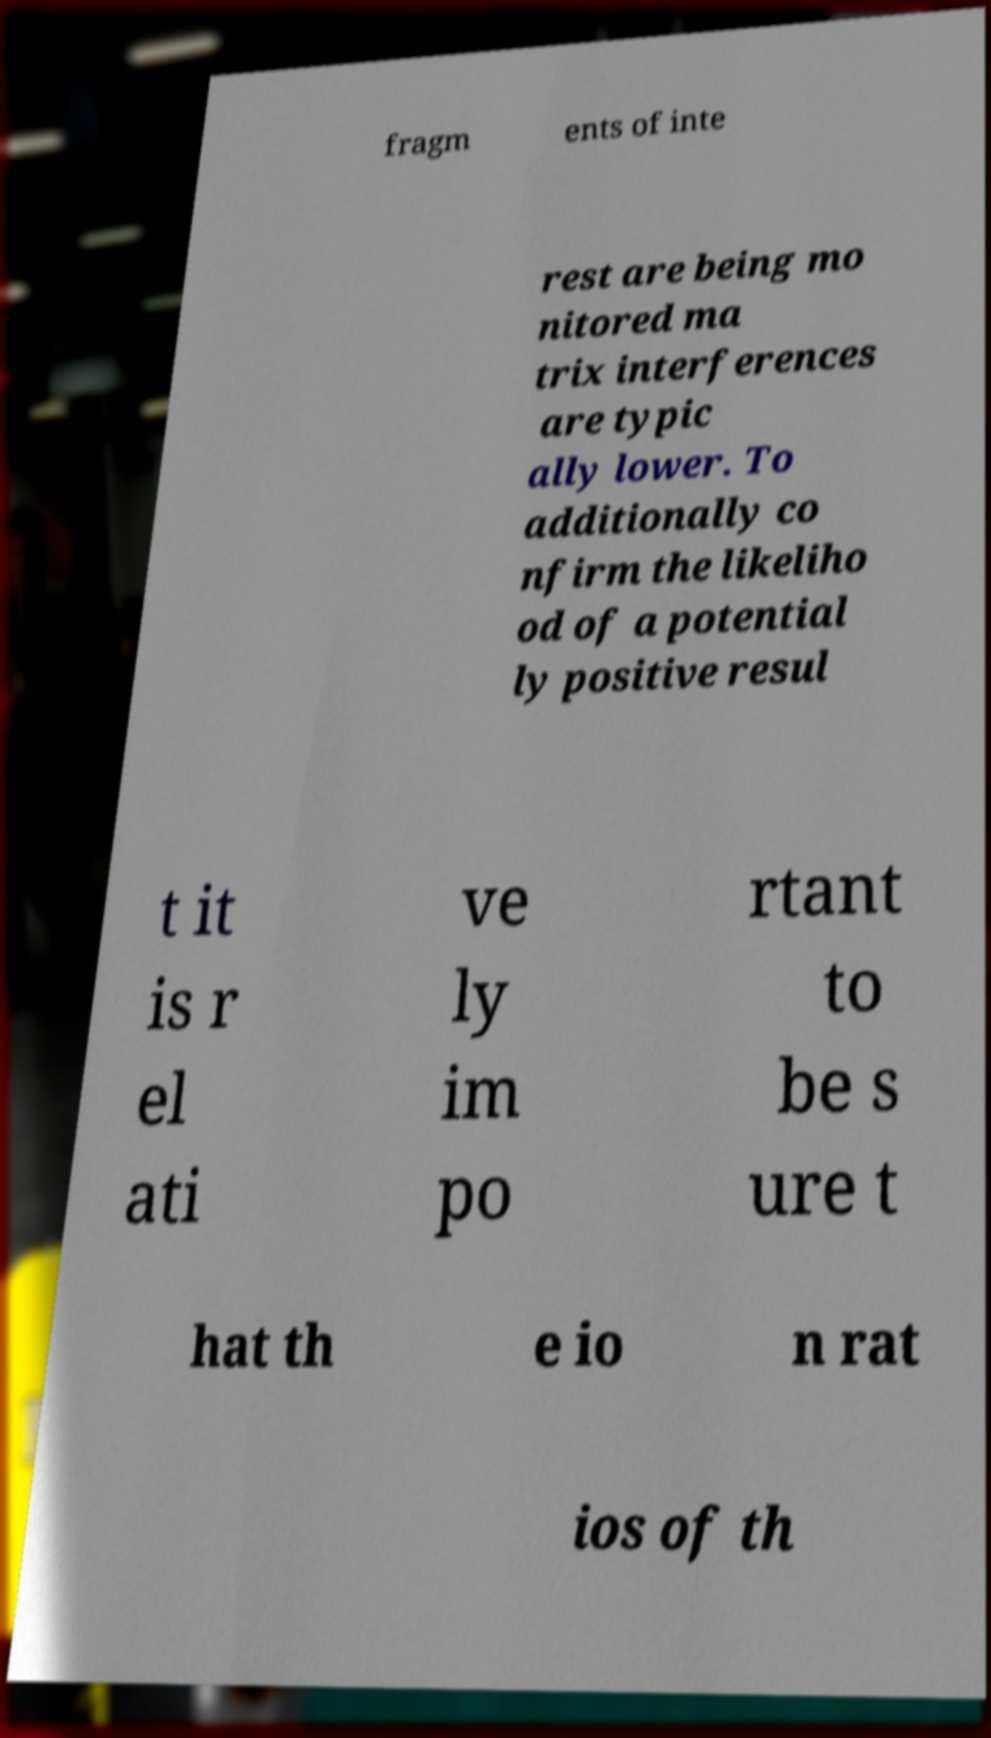There's text embedded in this image that I need extracted. Can you transcribe it verbatim? fragm ents of inte rest are being mo nitored ma trix interferences are typic ally lower. To additionally co nfirm the likeliho od of a potential ly positive resul t it is r el ati ve ly im po rtant to be s ure t hat th e io n rat ios of th 